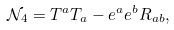<formula> <loc_0><loc_0><loc_500><loc_500>\mathcal { N } _ { 4 } = T ^ { a } T _ { a } - e ^ { a } e ^ { b } R _ { a b } ,</formula> 